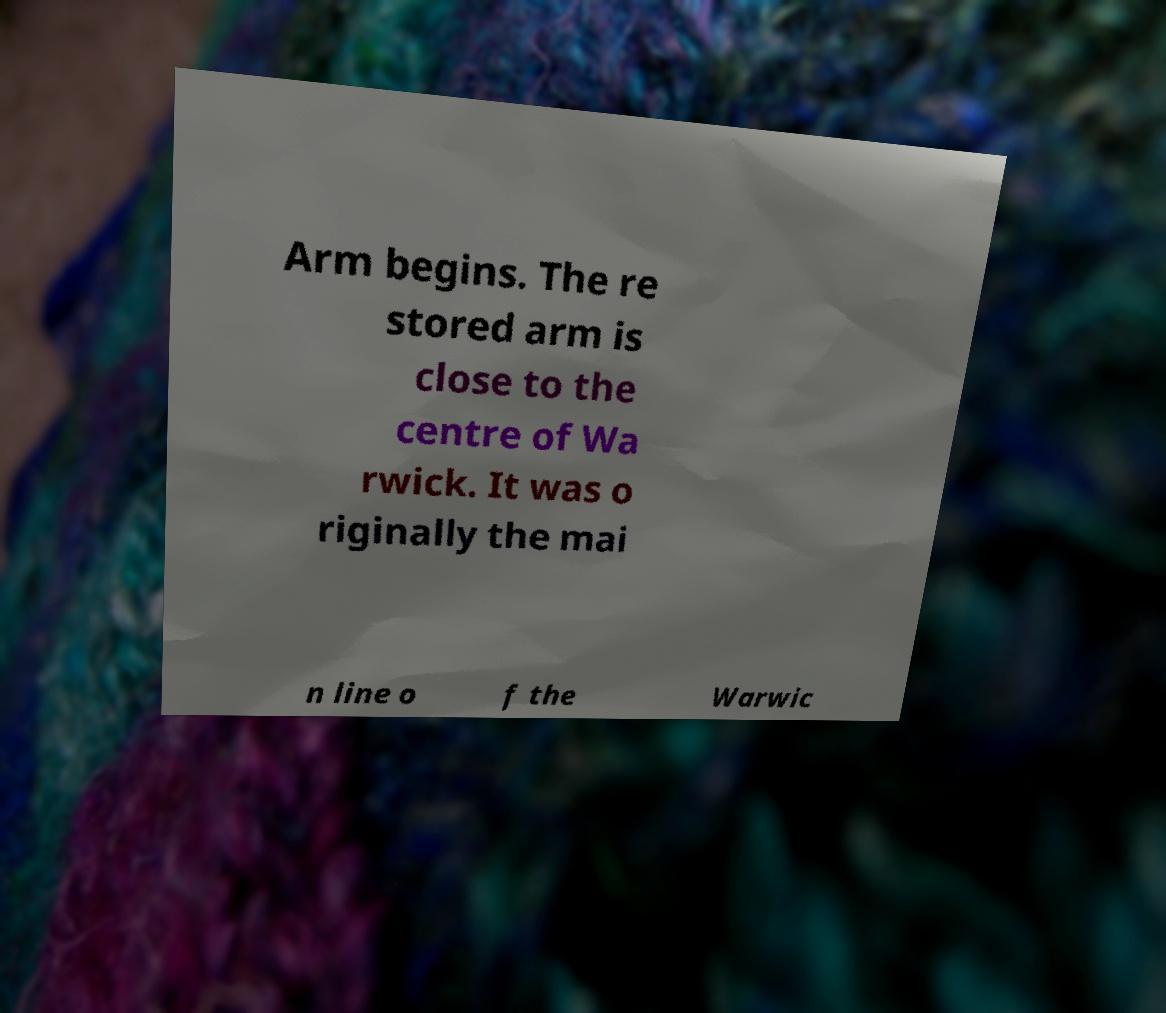Can you accurately transcribe the text from the provided image for me? Arm begins. The re stored arm is close to the centre of Wa rwick. It was o riginally the mai n line o f the Warwic 